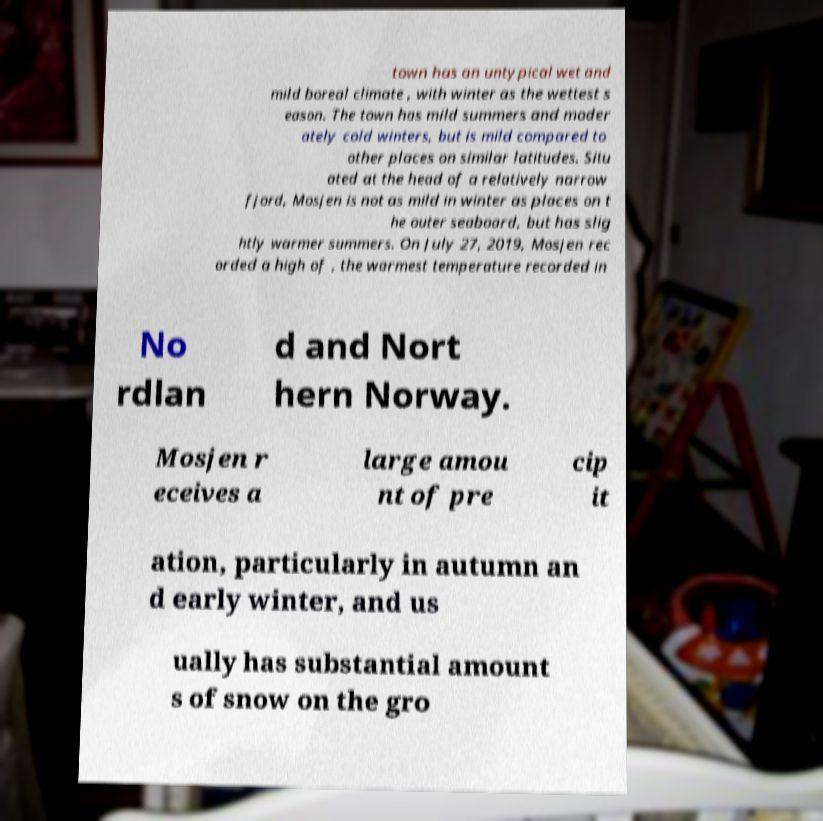Can you read and provide the text displayed in the image?This photo seems to have some interesting text. Can you extract and type it out for me? town has an untypical wet and mild boreal climate , with winter as the wettest s eason. The town has mild summers and moder ately cold winters, but is mild compared to other places on similar latitudes. Situ ated at the head of a relatively narrow fjord, Mosjen is not as mild in winter as places on t he outer seaboard, but has slig htly warmer summers. On July 27, 2019, Mosjen rec orded a high of , the warmest temperature recorded in No rdlan d and Nort hern Norway. Mosjen r eceives a large amou nt of pre cip it ation, particularly in autumn an d early winter, and us ually has substantial amount s of snow on the gro 